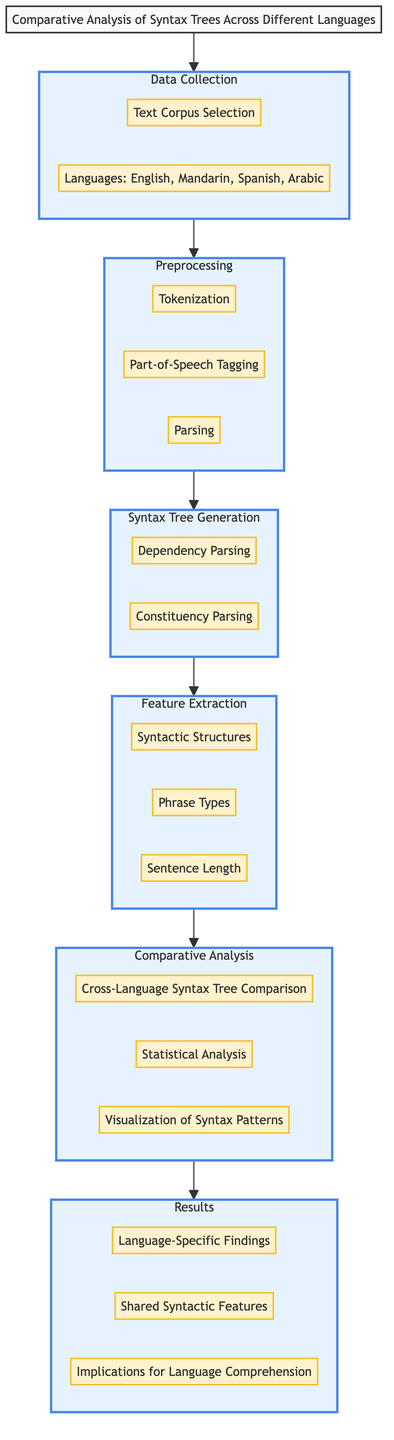What are the languages included in the data collection block? The data collection block lists the languages involved in the analysis. By referring to the block labeled "Data Collection," we see the component "Languages: English, Mandarin, Spanish, Arabic."
Answer: English, Mandarin, Spanish, Arabic How many components are there in the preprocessing block? The preprocessing block contains three components: "Tokenization," "Part-of-Speech Tagging," and "Parsing." Counting these gives us a total of three components.
Answer: 3 What is the final block in the diagram? Tracing the flow of the diagram from the title to the last block leads us to the “Results” block, which is the final block.
Answer: Results Which block follows syntax tree generation? Following the flow of the diagram from the "Syntax Tree Generation" block, the next block is "Feature Extraction." The diagram indicates a direct connection from "Syntax Tree Generation" to "Feature Extraction."
Answer: Feature Extraction What component measures sentence length? Within the "Feature Extraction" block, the component "Sentence Length" specifically measures this characteristic. By identifying this component from the block, we can provide the answer.
Answer: Sentence Length What type of analysis is performed in the comparative analysis block? In the "Comparative Analysis" block, three components are present, one of which is "Statistical Analysis," indicating the type of analysis performed there. This can be determined by inspecting the components listed under the "Comparative Analysis" block.
Answer: Statistical Analysis How many blocks are in the diagram entirely? The diagram consists of six blocks: "Data Collection," "Preprocessing," "Syntax Tree Generation," "Feature Extraction," "Comparative Analysis," and "Results." By counting these sequentially leads to the total.
Answer: 6 What is the purpose of the component in the analysis block? The "Comparative Analysis" block has three main components: "Cross-Language Syntax Tree Comparison," "Statistical Analysis," and "Visualization of Syntax Patterns." These components collectively aim to analyze syntax across different languages. Referring to the node allows us to identify the purpose.
Answer: Analyze syntax across languages 